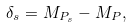<formula> <loc_0><loc_0><loc_500><loc_500>\delta _ { s } = M _ { P _ { s } } - M _ { P } ,</formula> 